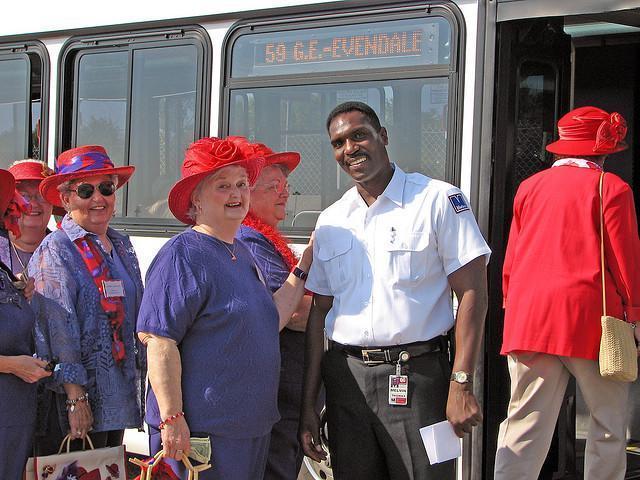How many handbags are in the photo?
Give a very brief answer. 2. How many people are in the picture?
Give a very brief answer. 7. How many zebras are there?
Give a very brief answer. 0. 